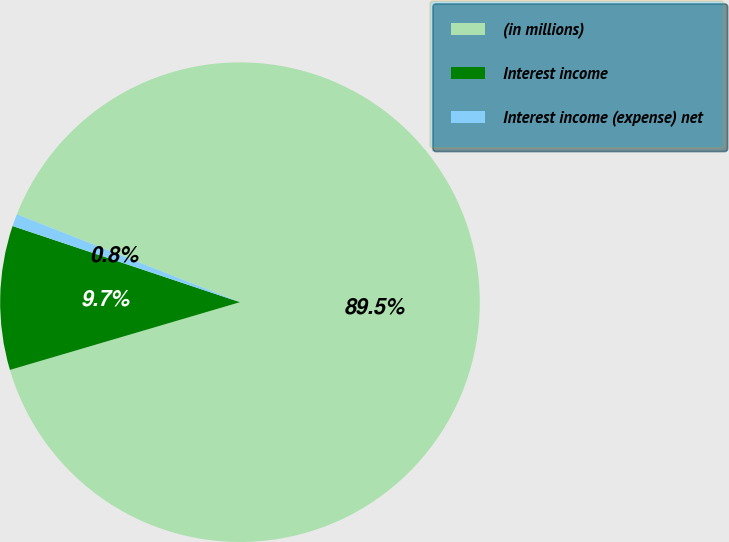Convert chart to OTSL. <chart><loc_0><loc_0><loc_500><loc_500><pie_chart><fcel>(in millions)<fcel>Interest income<fcel>Interest income (expense) net<nl><fcel>89.47%<fcel>9.7%<fcel>0.83%<nl></chart> 